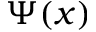Convert formula to latex. <formula><loc_0><loc_0><loc_500><loc_500>\Psi ( x )</formula> 